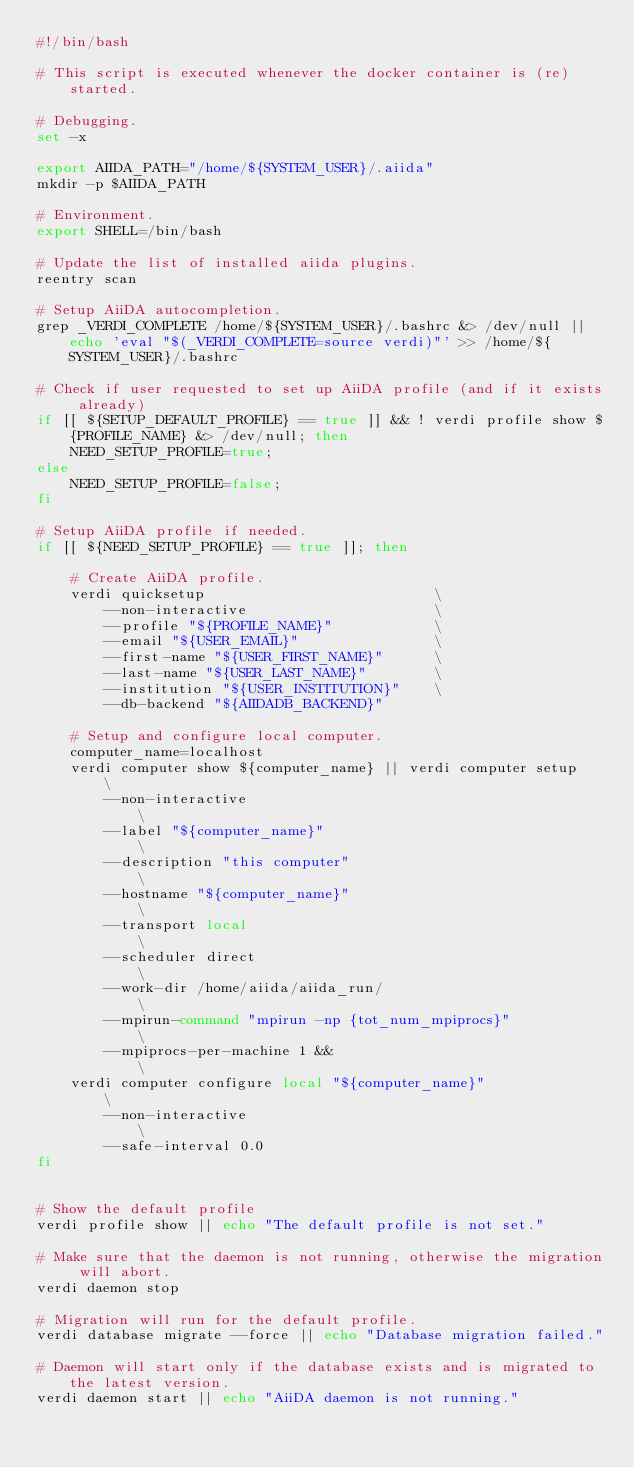<code> <loc_0><loc_0><loc_500><loc_500><_Bash_>#!/bin/bash

# This script is executed whenever the docker container is (re)started.

# Debugging.
set -x

export AIIDA_PATH="/home/${SYSTEM_USER}/.aiida"
mkdir -p $AIIDA_PATH

# Environment.
export SHELL=/bin/bash

# Update the list of installed aiida plugins.
reentry scan

# Setup AiiDA autocompletion.
grep _VERDI_COMPLETE /home/${SYSTEM_USER}/.bashrc &> /dev/null || echo 'eval "$(_VERDI_COMPLETE=source verdi)"' >> /home/${SYSTEM_USER}/.bashrc

# Check if user requested to set up AiiDA profile (and if it exists already)
if [[ ${SETUP_DEFAULT_PROFILE} == true ]] && ! verdi profile show ${PROFILE_NAME} &> /dev/null; then
    NEED_SETUP_PROFILE=true;
else
    NEED_SETUP_PROFILE=false;
fi

# Setup AiiDA profile if needed.
if [[ ${NEED_SETUP_PROFILE} == true ]]; then

    # Create AiiDA profile.
    verdi quicksetup                           \
        --non-interactive                      \
        --profile "${PROFILE_NAME}"            \
        --email "${USER_EMAIL}"                \
        --first-name "${USER_FIRST_NAME}"      \
        --last-name "${USER_LAST_NAME}"        \
        --institution "${USER_INSTITUTION}"    \
        --db-backend "${AIIDADB_BACKEND}"

    # Setup and configure local computer.
    computer_name=localhost
    verdi computer show ${computer_name} || verdi computer setup   \
        --non-interactive                                          \
        --label "${computer_name}"                                 \
        --description "this computer"                              \
        --hostname "${computer_name}"                              \
        --transport local                                          \
        --scheduler direct                                         \
        --work-dir /home/aiida/aiida_run/                          \
        --mpirun-command "mpirun -np {tot_num_mpiprocs}"           \
        --mpiprocs-per-machine 1 &&                                \
    verdi computer configure local "${computer_name}"              \
        --non-interactive                                          \
        --safe-interval 0.0
fi


# Show the default profile
verdi profile show || echo "The default profile is not set."

# Make sure that the daemon is not running, otherwise the migration will abort.
verdi daemon stop

# Migration will run for the default profile.
verdi database migrate --force || echo "Database migration failed."

# Daemon will start only if the database exists and is migrated to the latest version.
verdi daemon start || echo "AiiDA daemon is not running."
</code> 